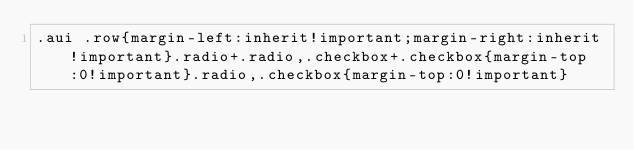<code> <loc_0><loc_0><loc_500><loc_500><_CSS_>.aui .row{margin-left:inherit!important;margin-right:inherit!important}.radio+.radio,.checkbox+.checkbox{margin-top:0!important}.radio,.checkbox{margin-top:0!important}</code> 